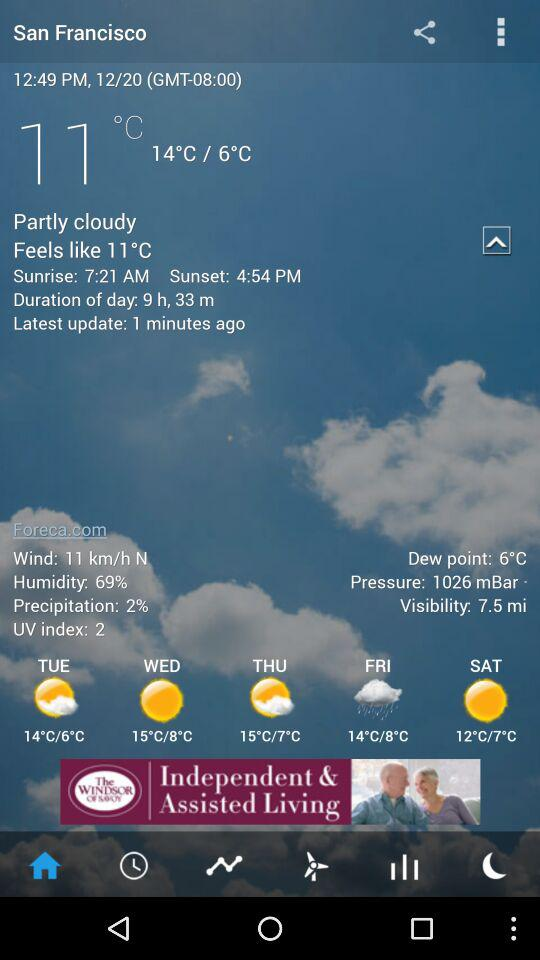What is the visibility? The visibility is 7.5 miles. 